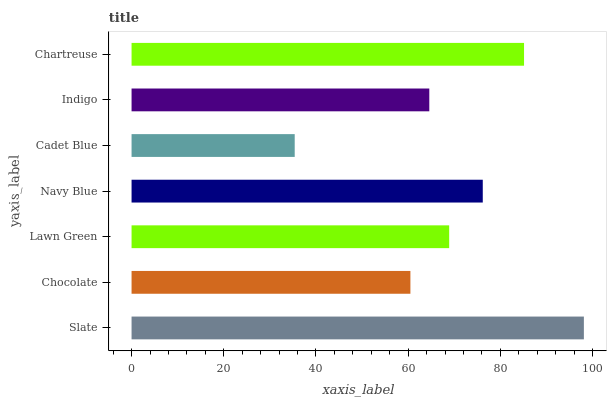Is Cadet Blue the minimum?
Answer yes or no. Yes. Is Slate the maximum?
Answer yes or no. Yes. Is Chocolate the minimum?
Answer yes or no. No. Is Chocolate the maximum?
Answer yes or no. No. Is Slate greater than Chocolate?
Answer yes or no. Yes. Is Chocolate less than Slate?
Answer yes or no. Yes. Is Chocolate greater than Slate?
Answer yes or no. No. Is Slate less than Chocolate?
Answer yes or no. No. Is Lawn Green the high median?
Answer yes or no. Yes. Is Lawn Green the low median?
Answer yes or no. Yes. Is Cadet Blue the high median?
Answer yes or no. No. Is Indigo the low median?
Answer yes or no. No. 